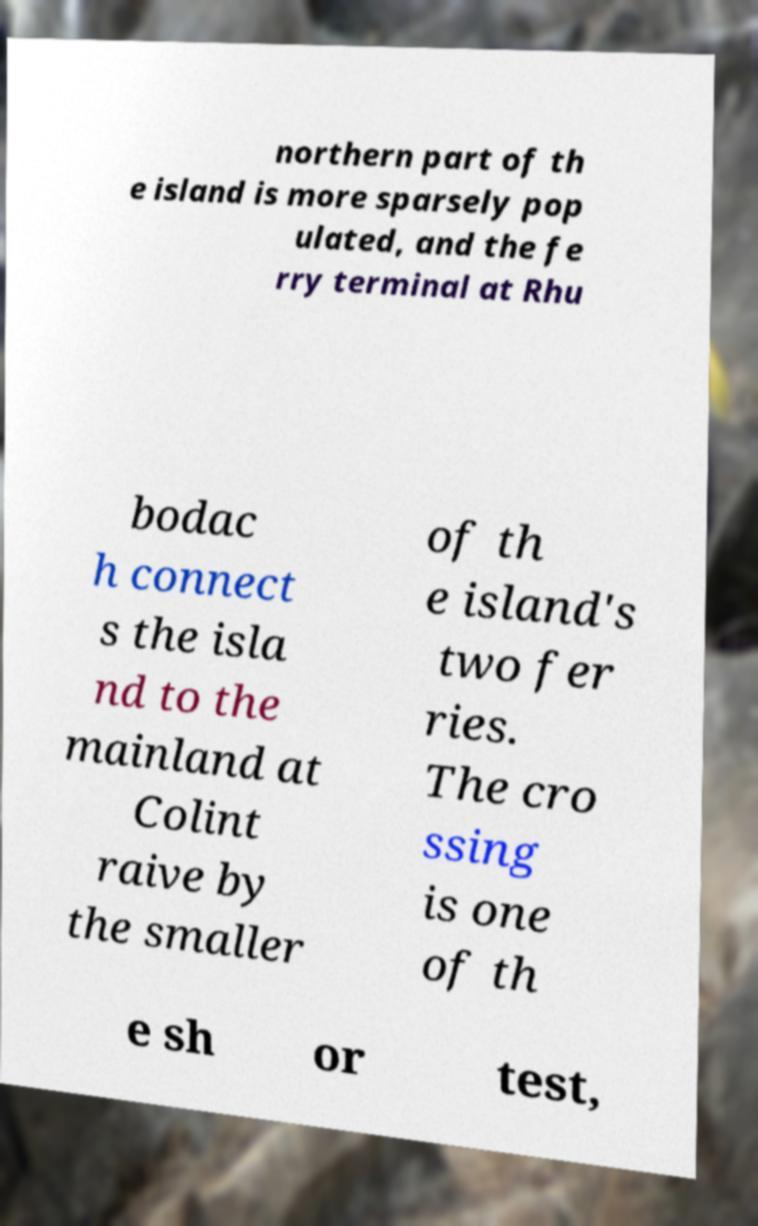Can you accurately transcribe the text from the provided image for me? northern part of th e island is more sparsely pop ulated, and the fe rry terminal at Rhu bodac h connect s the isla nd to the mainland at Colint raive by the smaller of th e island's two fer ries. The cro ssing is one of th e sh or test, 